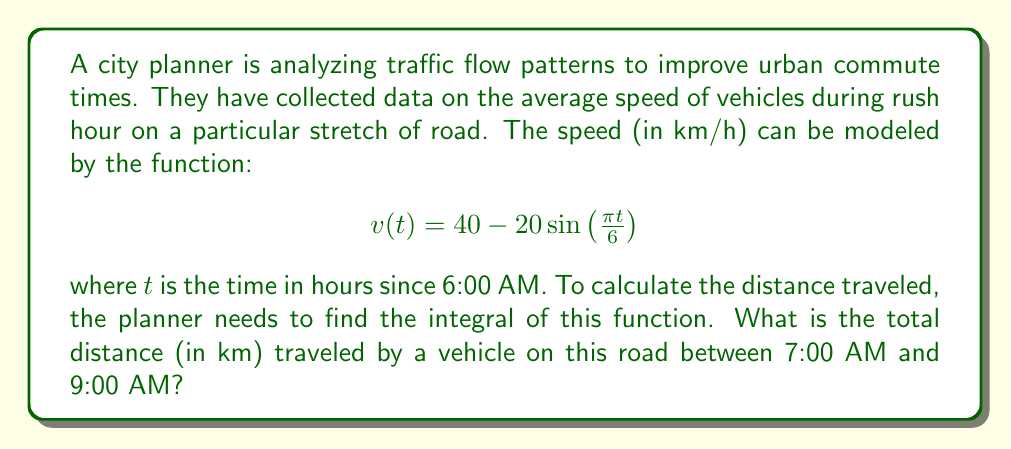Teach me how to tackle this problem. Let's approach this step-by-step:

1) The distance traveled is the integral of the velocity function over time. We need to integrate $v(t)$ from $t=1$ (7:00 AM) to $t=3$ (9:00 AM).

2) Set up the integral:
   $$\int_{1}^{3} \left(40 - 20\sin\left(\frac{\pi t}{6}\right)\right) dt$$

3) Split the integral:
   $$\int_{1}^{3} 40 dt - \int_{1}^{3} 20\sin\left(\frac{\pi t}{6}\right) dt$$

4) Solve the first part:
   $$40t \bigg|_{1}^{3} = 40(3) - 40(1) = 80$$

5) For the second part, use u-substitution:
   Let $u = \frac{\pi t}{6}$, then $du = \frac{\pi}{6}dt$ or $dt = \frac{6}{\pi}du$
   New limits: when $t=1$, $u=\frac{\pi}{6}$; when $t=3$, $u=\frac{\pi}{2}$

6) Rewrite the second integral:
   $$-20 \cdot \frac{6}{\pi} \int_{\pi/6}^{\pi/2} \sin(u) du$$

7) Solve:
   $$-\frac{120}{\pi} [-\cos(u)]_{\pi/6}^{\pi/2} = -\frac{120}{\pi} \left[-\cos\left(\frac{\pi}{2}\right) + \cos\left(\frac{\pi}{6}\right)\right]$$
   $$= -\frac{120}{\pi} \left[0 + \frac{\sqrt{3}}{2}\right] = -\frac{60\sqrt{3}}{\pi}$$

8) Combine results:
   $$80 + \frac{60\sqrt{3}}{\pi}$$

9) This is approximately 113.14 km.
Answer: $80 + \frac{60\sqrt{3}}{\pi}$ km 